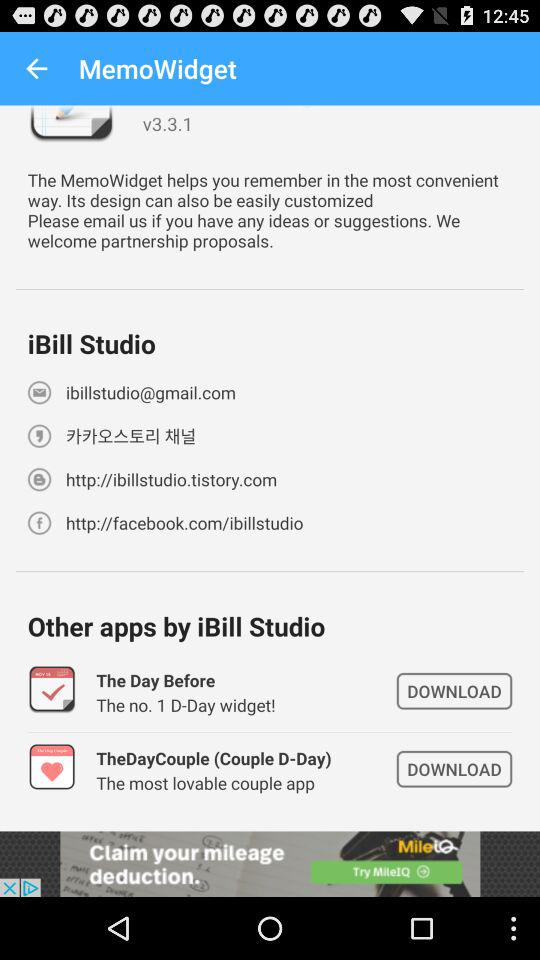What is the version? The version is v3.3.1. 